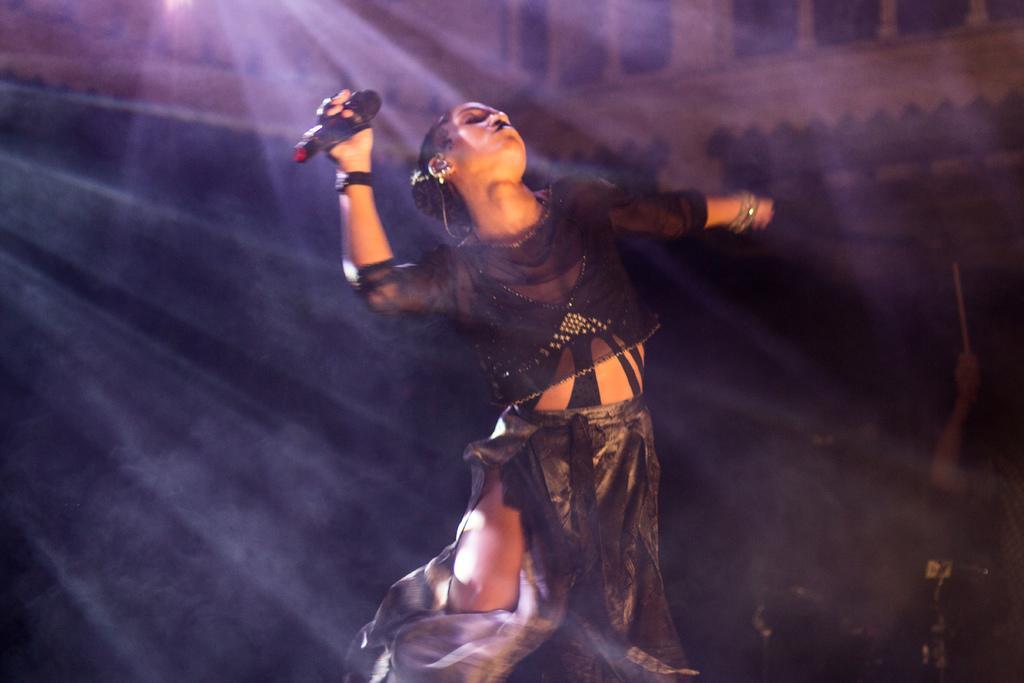In one or two sentences, can you explain what this image depicts? In the image there is a woman standing in a dancing poster, she is holding some object with her hand and in the background there is a person holding some object in the hand. 